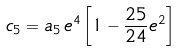<formula> <loc_0><loc_0><loc_500><loc_500>c _ { 5 } = a _ { 5 } \, e ^ { 4 } \left [ 1 - \frac { 2 5 } { 2 4 } e ^ { 2 } \right ]</formula> 